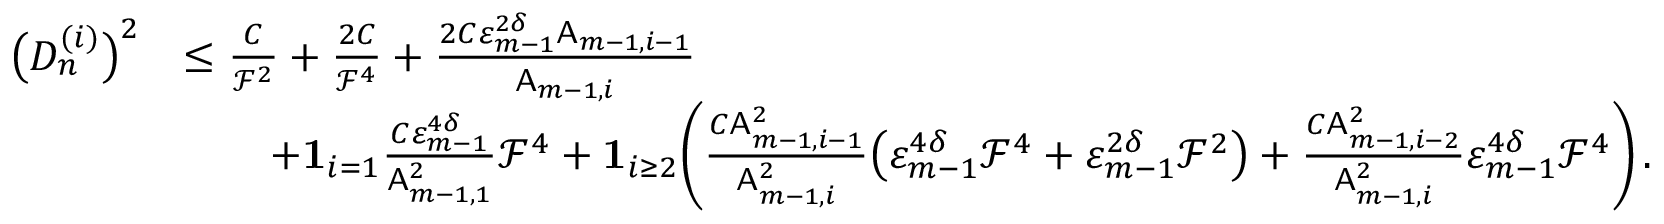Convert formula to latex. <formula><loc_0><loc_0><loc_500><loc_500>\begin{array} { r l } { \left ( D _ { n } ^ { ( i ) } \right ) ^ { 2 } } & { \leq \frac { C } { \mathcal { F } ^ { 2 } } + \frac { 2 C } { \mathcal { F } ^ { 4 } } + \frac { 2 C \varepsilon _ { m - 1 } ^ { 2 \delta } A _ { m - 1 , i - 1 } } { A _ { m - 1 , i } } } \\ & { \quad + { 1 } _ { i = 1 } \frac { C \varepsilon _ { m - 1 } ^ { 4 \delta } } { A _ { m - 1 , 1 } ^ { 2 } } \mathcal { F } ^ { 4 } + { 1 } _ { i \geq 2 } \left ( \frac { C A _ { m - 1 , i - 1 } ^ { 2 } } { A _ { m - 1 , i } ^ { 2 } } \left ( \varepsilon _ { m - 1 } ^ { 4 \delta } \mathcal { F } ^ { 4 } + \varepsilon _ { m - 1 } ^ { 2 \delta } \mathcal { F } ^ { 2 } \right ) + \frac { C A _ { m - 1 , i - 2 } ^ { 2 } } { A _ { m - 1 , i } ^ { 2 } } \varepsilon _ { m - 1 } ^ { 4 \delta } \mathcal { F } ^ { 4 } \right ) \, . } \end{array}</formula> 